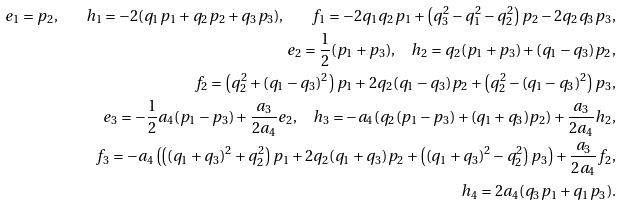Convert formula to latex. <formula><loc_0><loc_0><loc_500><loc_500>e _ { 1 } = p _ { 2 } , \quad h _ { 1 } = - 2 ( q _ { 1 } p _ { 1 } + q _ { 2 } p _ { 2 } + q _ { 3 } p _ { 3 } ) , \quad f _ { 1 } = - 2 q _ { 1 } q _ { 2 } p _ { 1 } + \left ( q _ { 3 } ^ { 2 } - q _ { 1 } ^ { 2 } - q _ { 2 } ^ { 2 } \right ) p _ { 2 } - 2 q _ { 2 } q _ { 3 } p _ { 3 } , \\ e _ { 2 } = \frac { 1 } { 2 } ( p _ { 1 } + p _ { 3 } ) , \quad h _ { 2 } = q _ { 2 } ( p _ { 1 } + p _ { 3 } ) + ( q _ { 1 } - q _ { 3 } ) p _ { 2 } , \\ f _ { 2 } = \left ( q _ { 2 } ^ { 2 } + ( q _ { 1 } - q _ { 3 } ) ^ { 2 } \right ) p _ { 1 } + 2 q _ { 2 } ( q _ { 1 } - q _ { 3 } ) p _ { 2 } + \left ( q _ { 2 } ^ { 2 } - ( q _ { 1 } - q _ { 3 } ) ^ { 2 } \right ) p _ { 3 } , \\ e _ { 3 } = - \frac { 1 } { 2 } a _ { 4 } ( p _ { 1 } - p _ { 3 } ) + \frac { a _ { 3 } } { 2 a _ { 4 } } e _ { 2 } , \quad h _ { 3 } = - a _ { 4 } ( q _ { 2 } ( p _ { 1 } - p _ { 3 } ) + ( q _ { 1 } + q _ { 3 } ) p _ { 2 } ) + \frac { a _ { 3 } } { 2 a _ { 4 } } h _ { 2 } , \\ f _ { 3 } = - a _ { 4 } \left ( \left ( ( q _ { 1 } + q _ { 3 } ) ^ { 2 } + q _ { 2 } ^ { 2 } \right ) p _ { 1 } + 2 q _ { 2 } ( q _ { 1 } + q _ { 3 } ) p _ { 2 } + \left ( ( q _ { 1 } + q _ { 3 } ) ^ { 2 } - q _ { 2 } ^ { 2 } \right ) p _ { 3 } \right ) + \frac { a _ { 3 } } { 2 a _ { 4 } } f _ { 2 } , \\ h _ { 4 } = 2 a _ { 4 } ( q _ { 3 } p _ { 1 } + q _ { 1 } p _ { 3 } ) .</formula> 